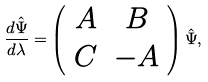Convert formula to latex. <formula><loc_0><loc_0><loc_500><loc_500>\frac { d \hat { \Psi } } { d \lambda } = \left ( \begin{array} { c c } A & B \\ C & - A \end{array} \right ) \hat { \Psi } ,</formula> 